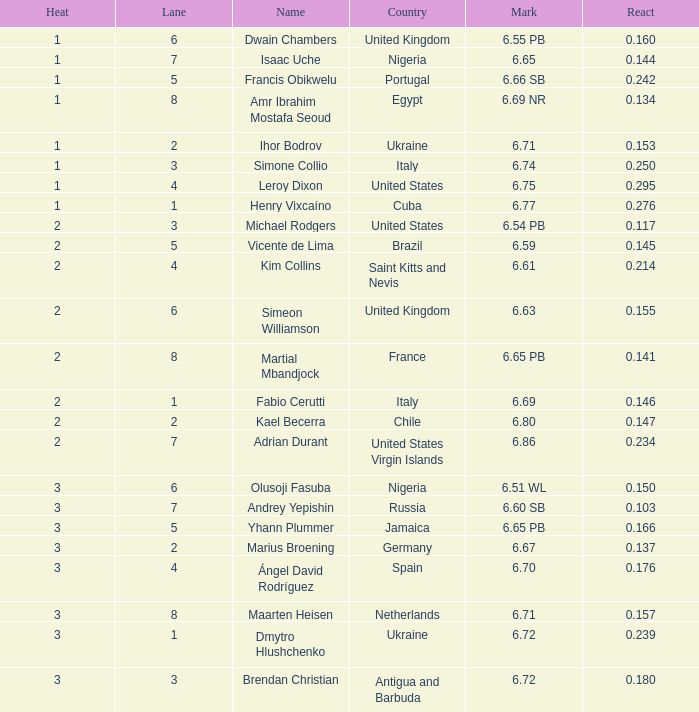What is Country, when Lane is 5, and when React is greater than 0.166? Portugal. 